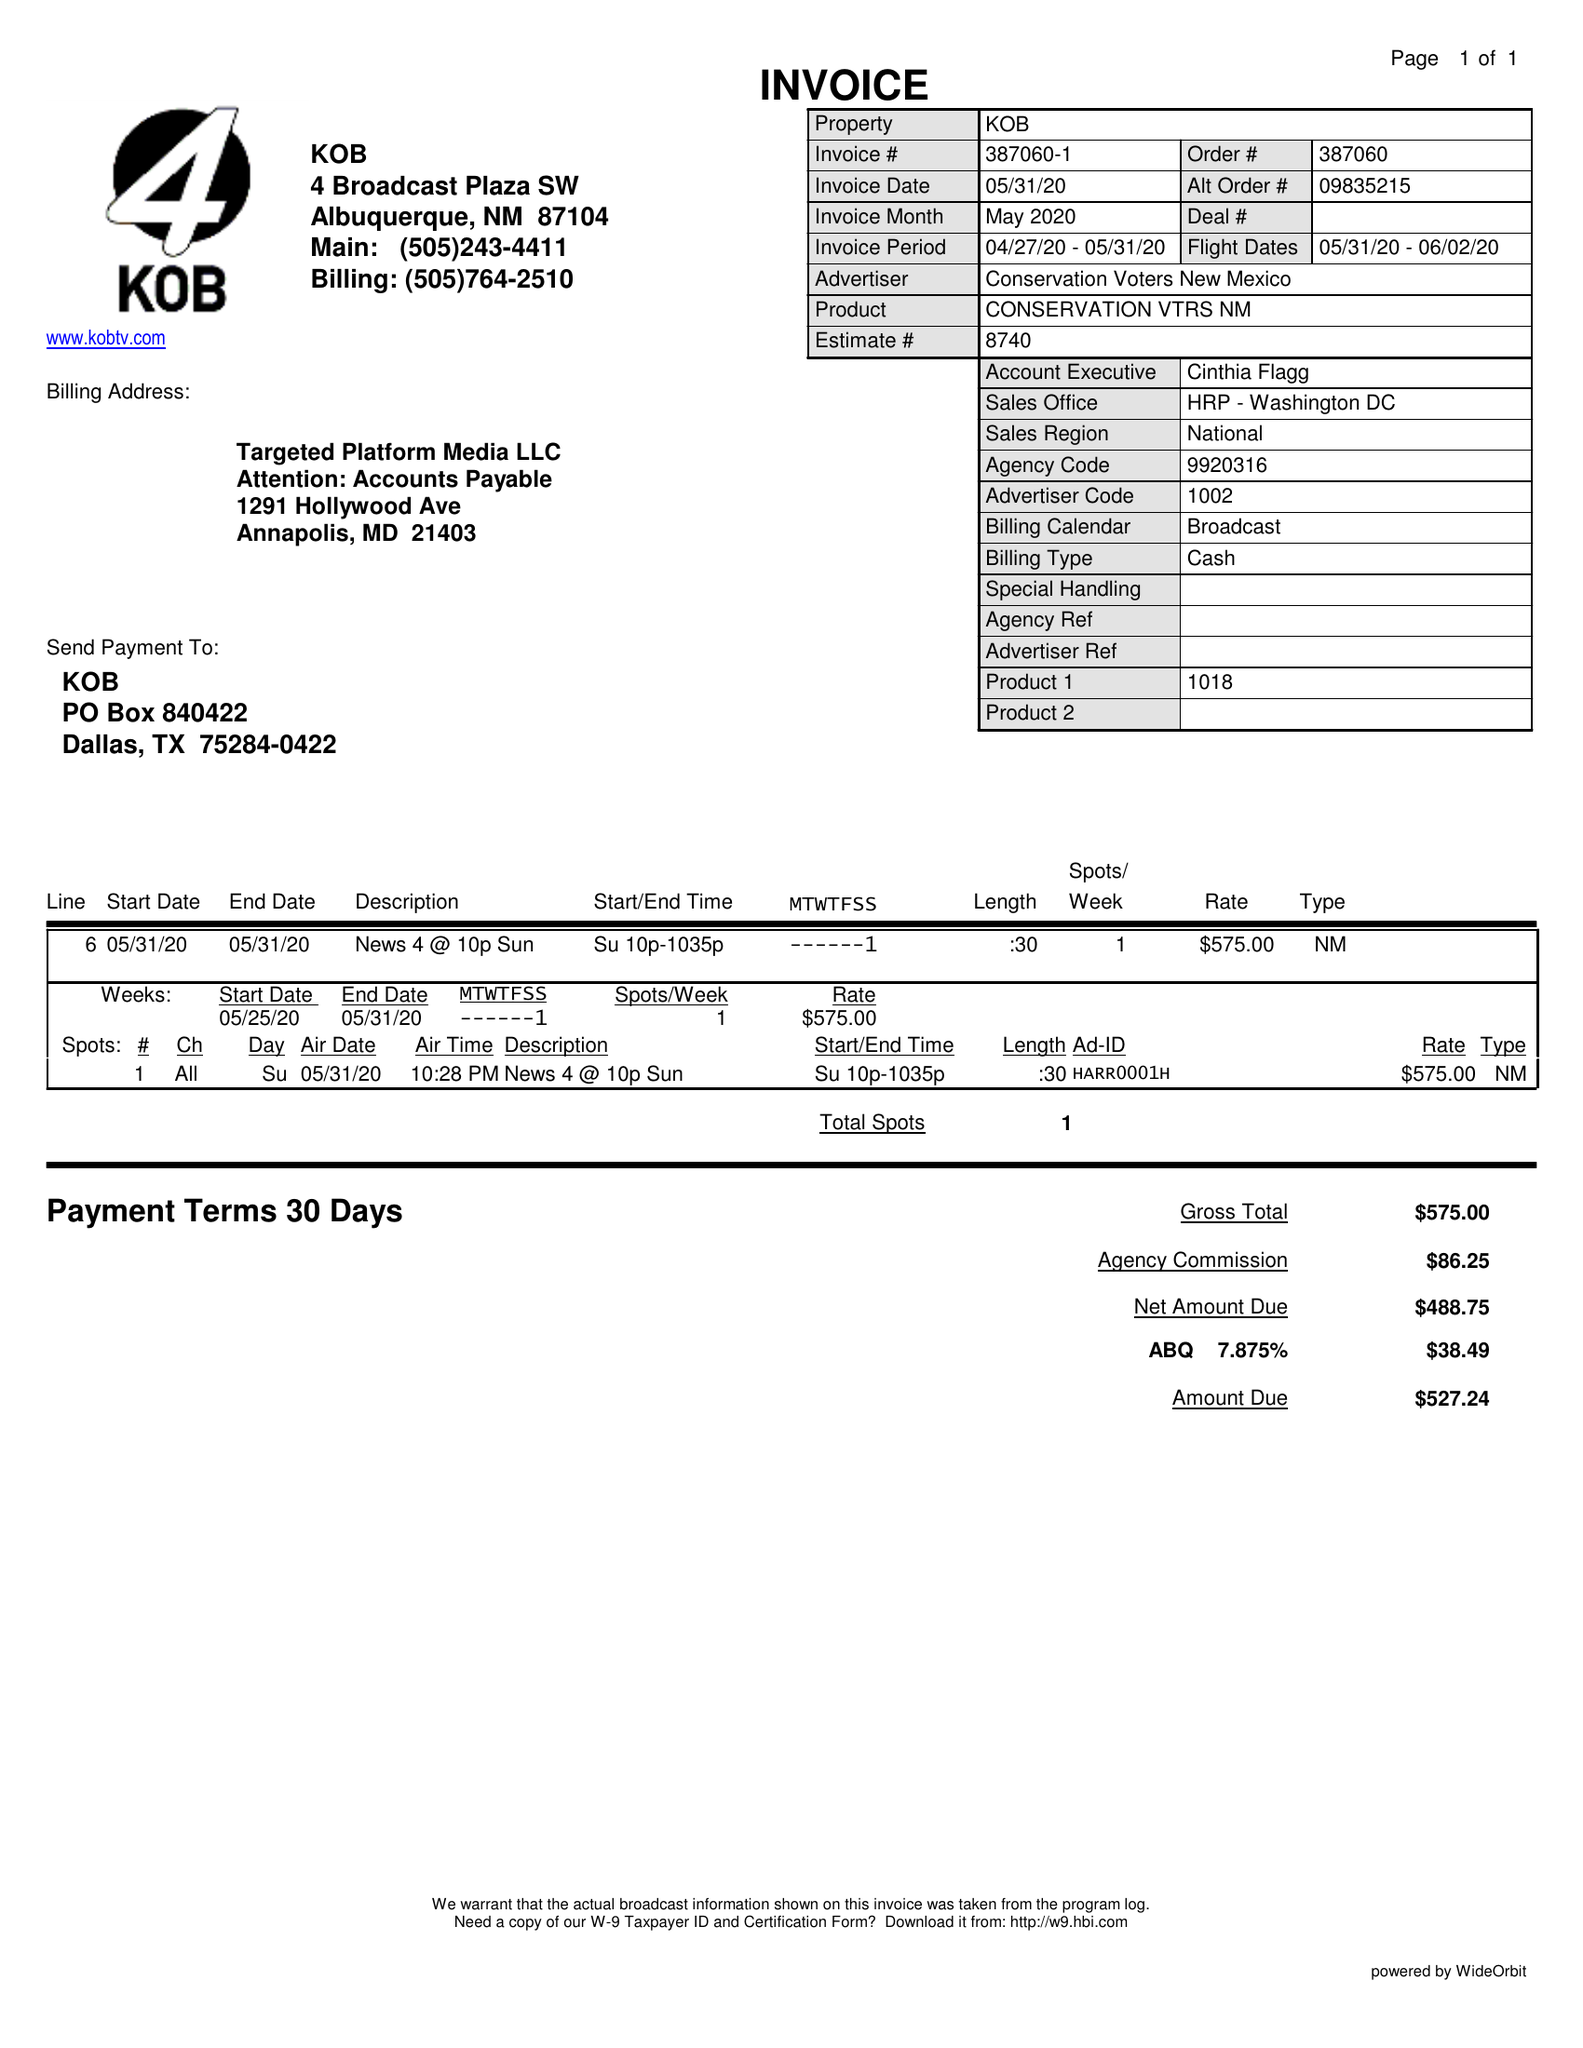What is the value for the advertiser?
Answer the question using a single word or phrase. CONSERVATION VOTERS NEW MEXICO 